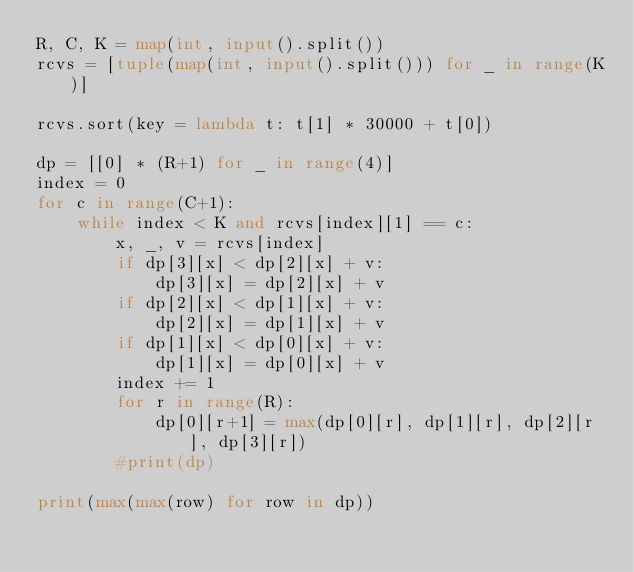<code> <loc_0><loc_0><loc_500><loc_500><_Python_>R, C, K = map(int, input().split())
rcvs = [tuple(map(int, input().split())) for _ in range(K)]

rcvs.sort(key = lambda t: t[1] * 30000 + t[0])

dp = [[0] * (R+1) for _ in range(4)]
index = 0
for c in range(C+1):
    while index < K and rcvs[index][1] == c:
        x, _, v = rcvs[index]
        if dp[3][x] < dp[2][x] + v:
            dp[3][x] = dp[2][x] + v
        if dp[2][x] < dp[1][x] + v:
            dp[2][x] = dp[1][x] + v
        if dp[1][x] < dp[0][x] + v:
            dp[1][x] = dp[0][x] + v
        index += 1
        for r in range(R):
            dp[0][r+1] = max(dp[0][r], dp[1][r], dp[2][r], dp[3][r])
        #print(dp)   
    
print(max(max(row) for row in dp))
</code> 